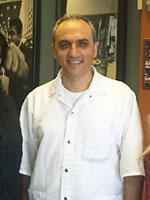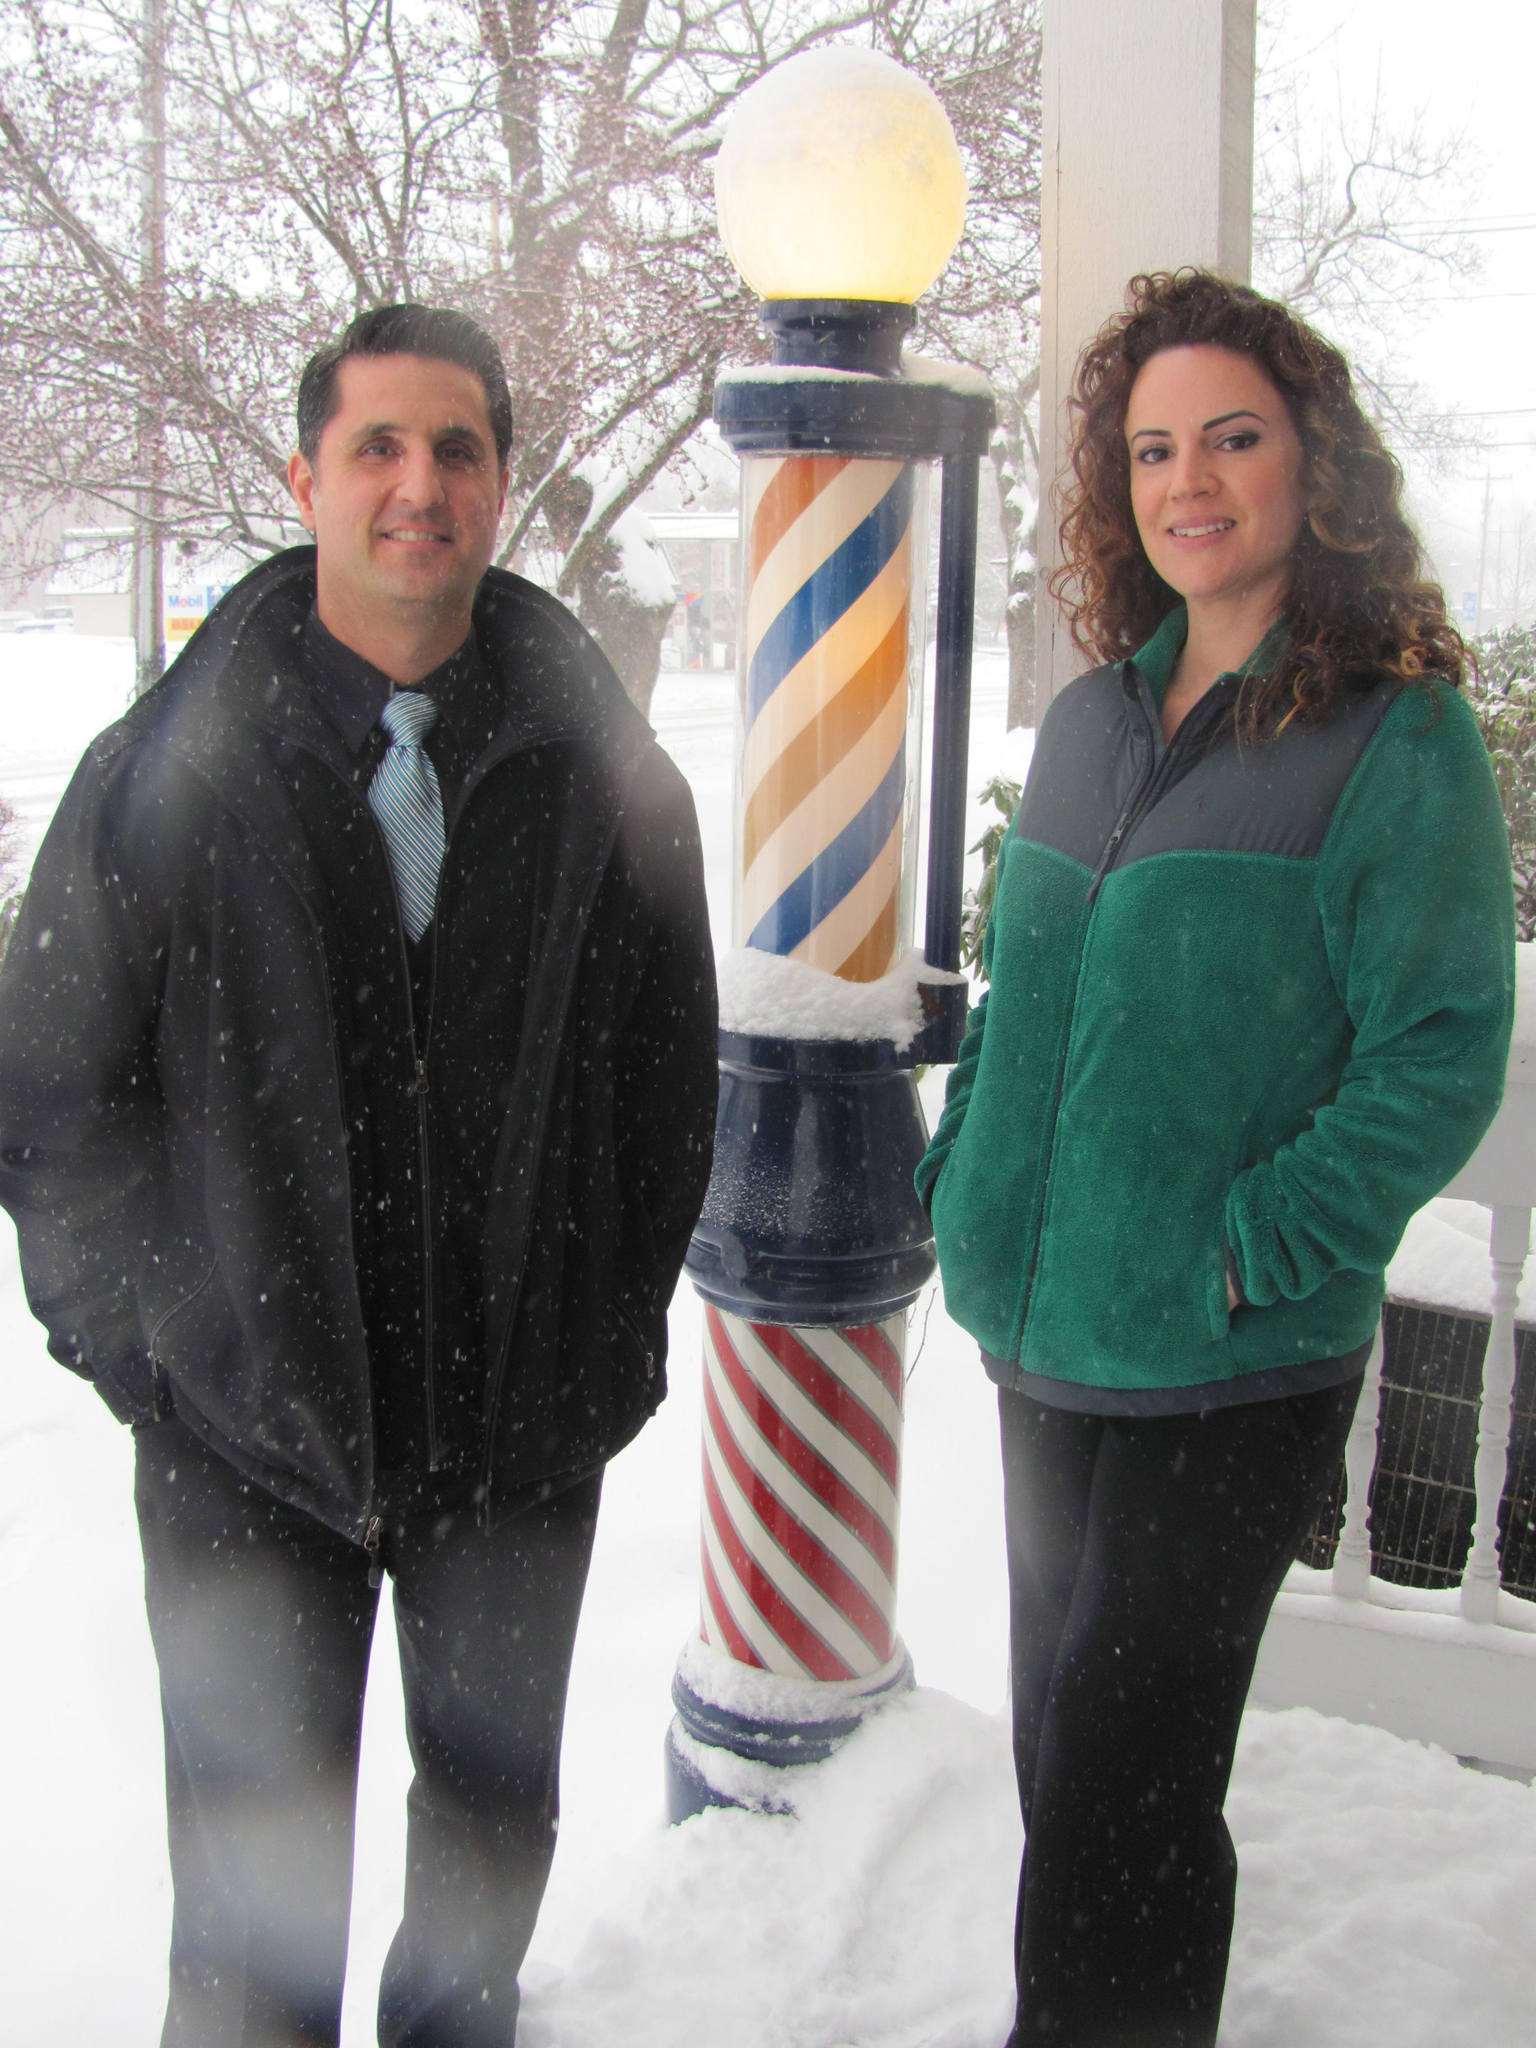The first image is the image on the left, the second image is the image on the right. Assess this claim about the two images: "An image shows at least one person standing by an outdoor barber pole.". Correct or not? Answer yes or no. Yes. The first image is the image on the left, the second image is the image on the right. Assess this claim about the two images: "In one image, a child is draped in a barber's cape and getting a haircut". Correct or not? Answer yes or no. No. 